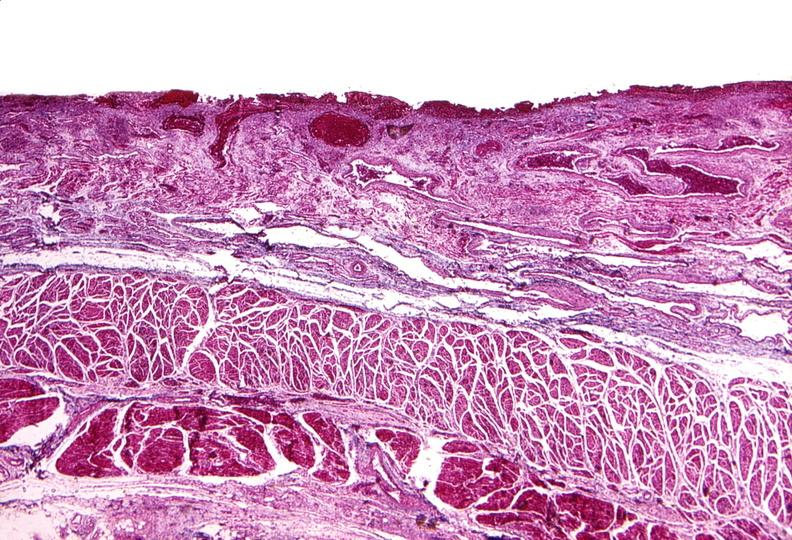does leiomyosarcoma show esophagus, varices?
Answer the question using a single word or phrase. No 